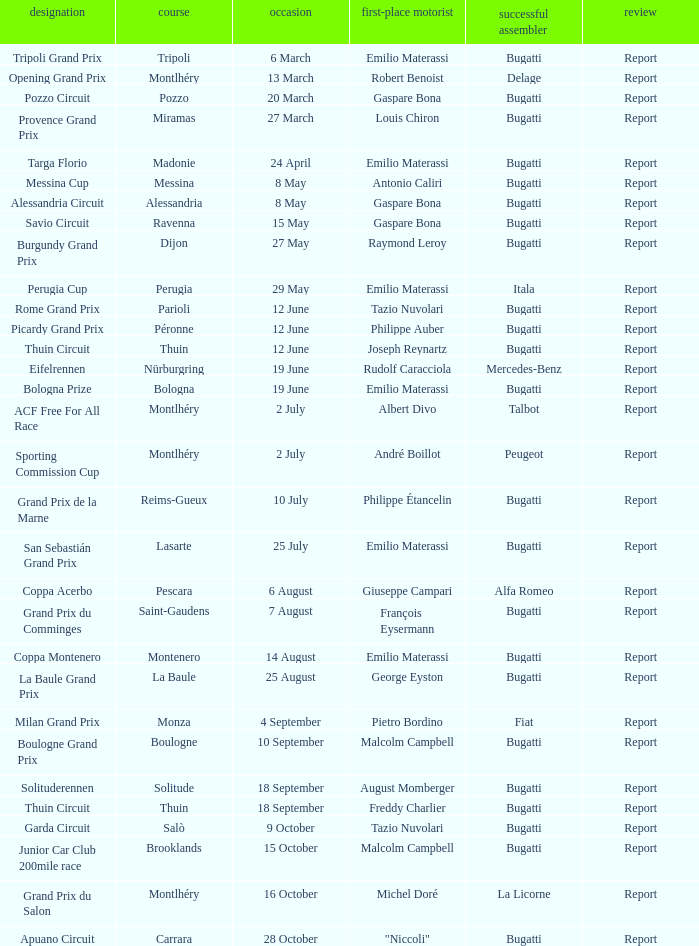Who was the winning constructor at the circuit of parioli? Bugatti. 